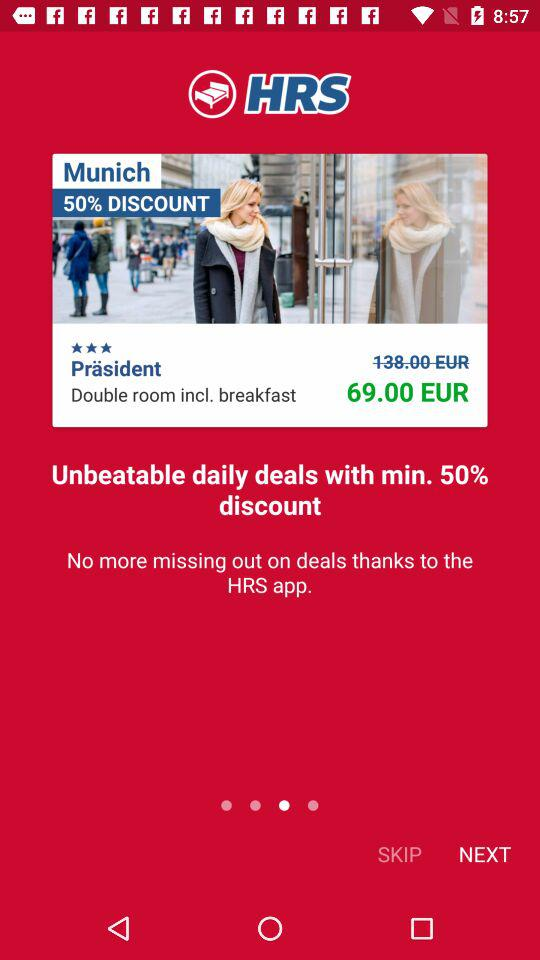How many beds are in the room?
When the provided information is insufficient, respond with <no answer>. <no answer> 